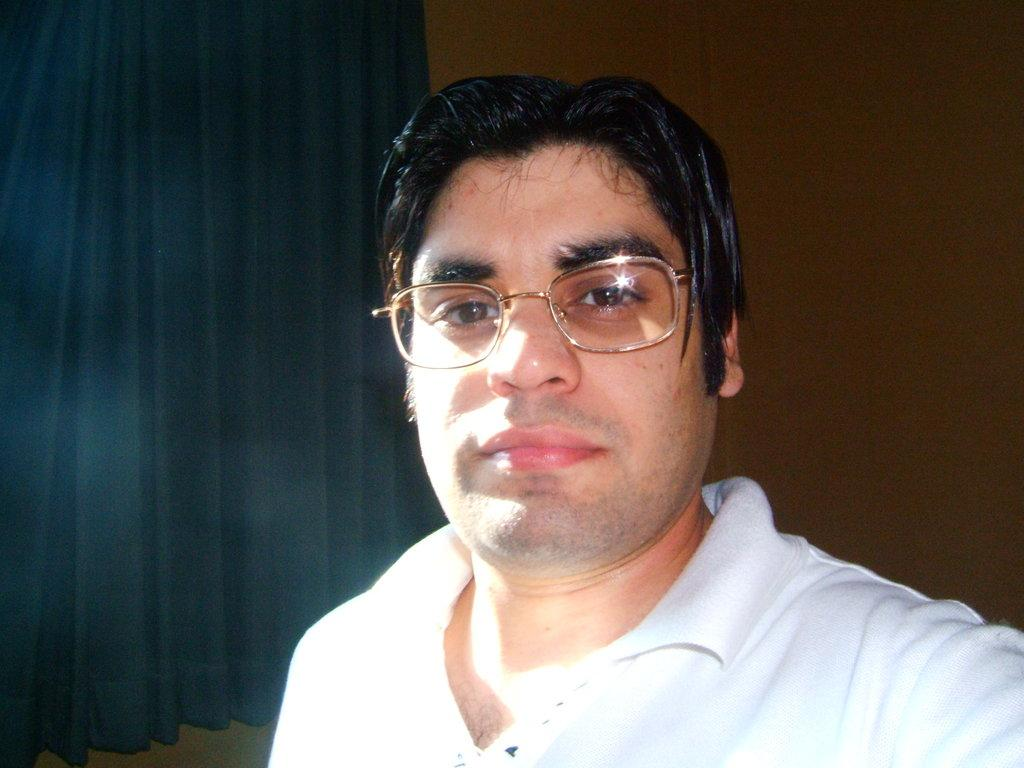What can be seen in the background of the image? There is a curtain and a wall in the background of the image. Who is present in the image? There is a man in the image. What is the man wearing? The man is wearing spectacles. What type of soup is the man eating in the image? There is no soup present in the image; the man is wearing spectacles. How many trucks can be seen in the image? There are no trucks present in the image. 